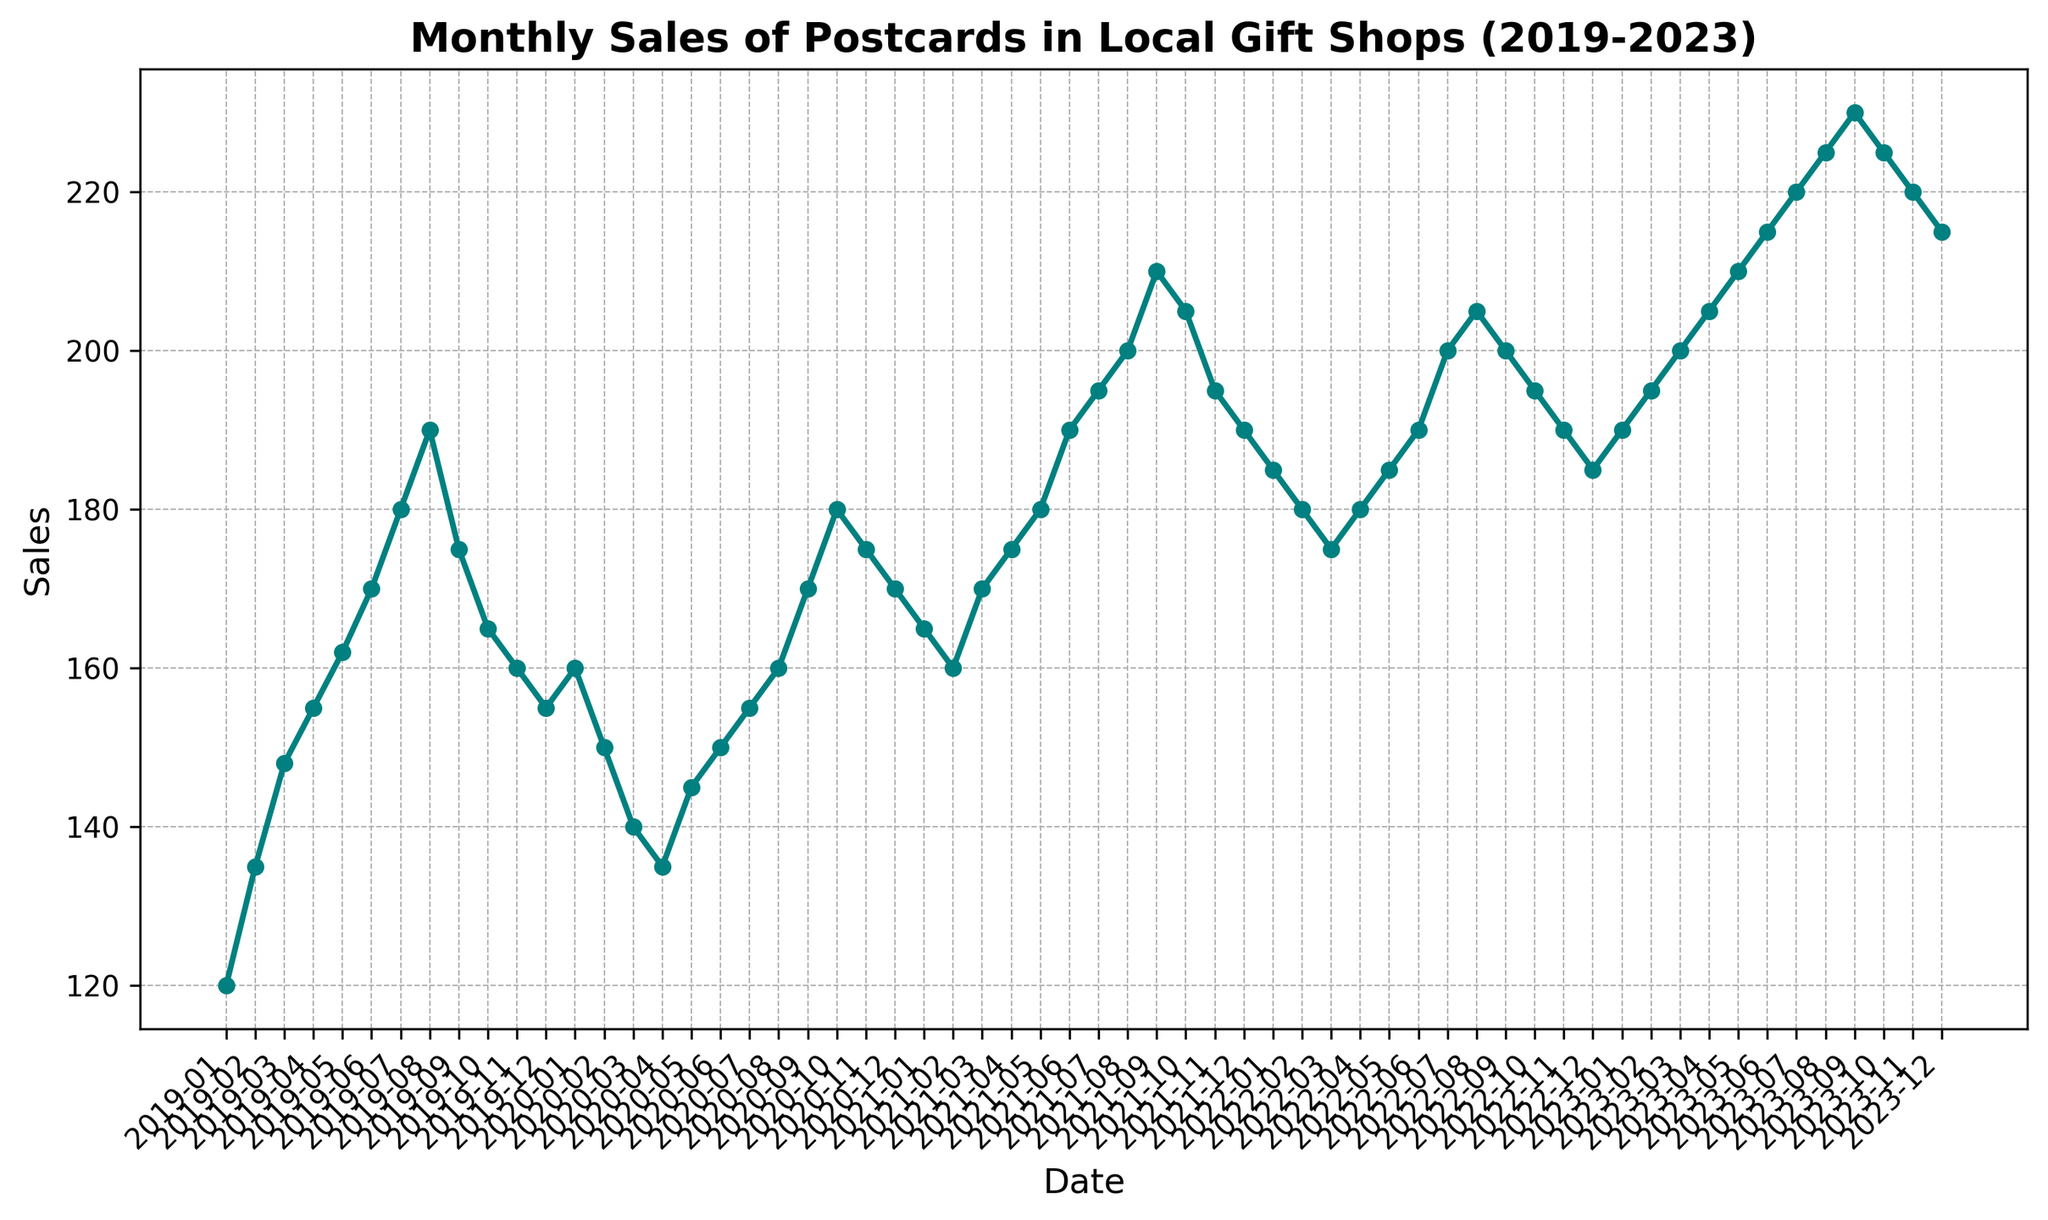Which month in 2023 had the highest sales? To find the highest sales month in 2023, look at the highest point in the chart for the year 2023. September 2023 shows the peak sales.
Answer: September 2023 How did the sales in December 2021 compare to December 2022? Compare the chart points for December 2021 and December 2022. December 2021 has a sales figure of 190, while December 2022 has a sales figure of 185.
Answer: Sales in December 2021 were higher What was the trend in sales from January 2020 to December 2020? From the chart, observe the sales figures for the whole year of 2020. The sales start at 160 in January, dip until April at 135, and then gradually rise to 170 by December.
Answer: They dipped initially and then rose Calculate the average monthly sales for the year 2021. Sum the monthly sales for 2021 (165 + 160 + 170 + 175 + 180 + 190 + 195 + 200 + 210 + 205 + 195 + 190 = 2235) and divide by 12.
Answer: 186.25 Did sales generally increase or decrease over the 5-year period? Look at the overall trend from 2019 to 2023. Sales generally increased from 120 in January 2019 to 225 in October 2023, despite some fluctuations.
Answer: Increased Where do we see the most significant month-to-month increase in sales? Check the chart for the steepest upward slope between consecutive months. The largest jump is between August 2023 (225) and September 2023 (230).
Answer: Between August 2023 and September 2023 Compare the sales trend in 2019 with sales in 2020. Which year experienced more volatility? Observing the two lines for 2019 and 2020, sales in 2020 show a greater drop early in the year and more fluctuation compared to the steady increase and slight dip in 2019.
Answer: 2020 was more volatile What month had the lowest sales in the entire data span? Identify the lowest point on the entire chart, which is April 2020 with sales of 135.
Answer: April 2020 